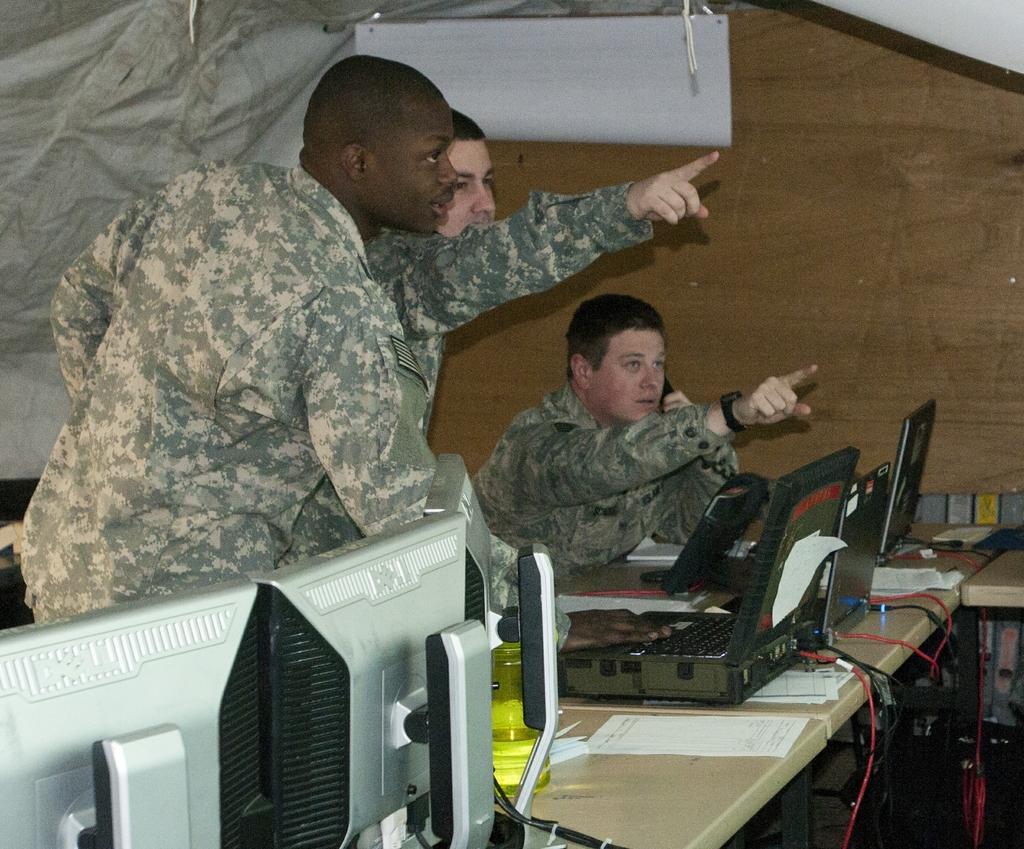Please provide a concise description of this image. Two men are standing, a man is sitting. There are monitors, papers, laptop is present is present on the table. 